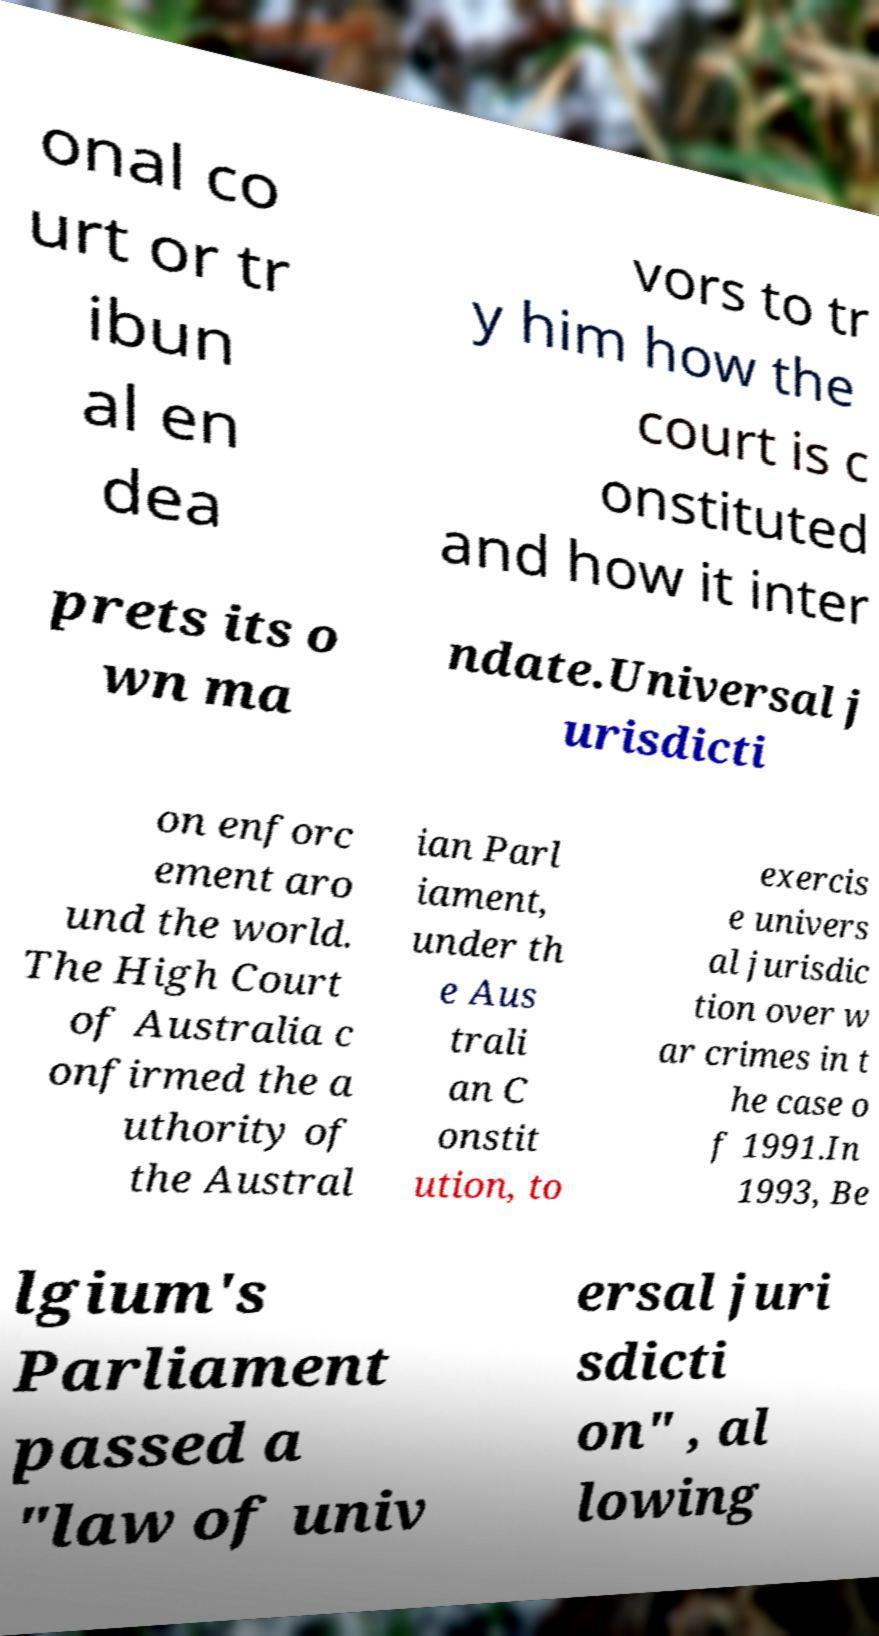Please identify and transcribe the text found in this image. onal co urt or tr ibun al en dea vors to tr y him how the court is c onstituted and how it inter prets its o wn ma ndate.Universal j urisdicti on enforc ement aro und the world. The High Court of Australia c onfirmed the a uthority of the Austral ian Parl iament, under th e Aus trali an C onstit ution, to exercis e univers al jurisdic tion over w ar crimes in t he case o f 1991.In 1993, Be lgium's Parliament passed a "law of univ ersal juri sdicti on" , al lowing 